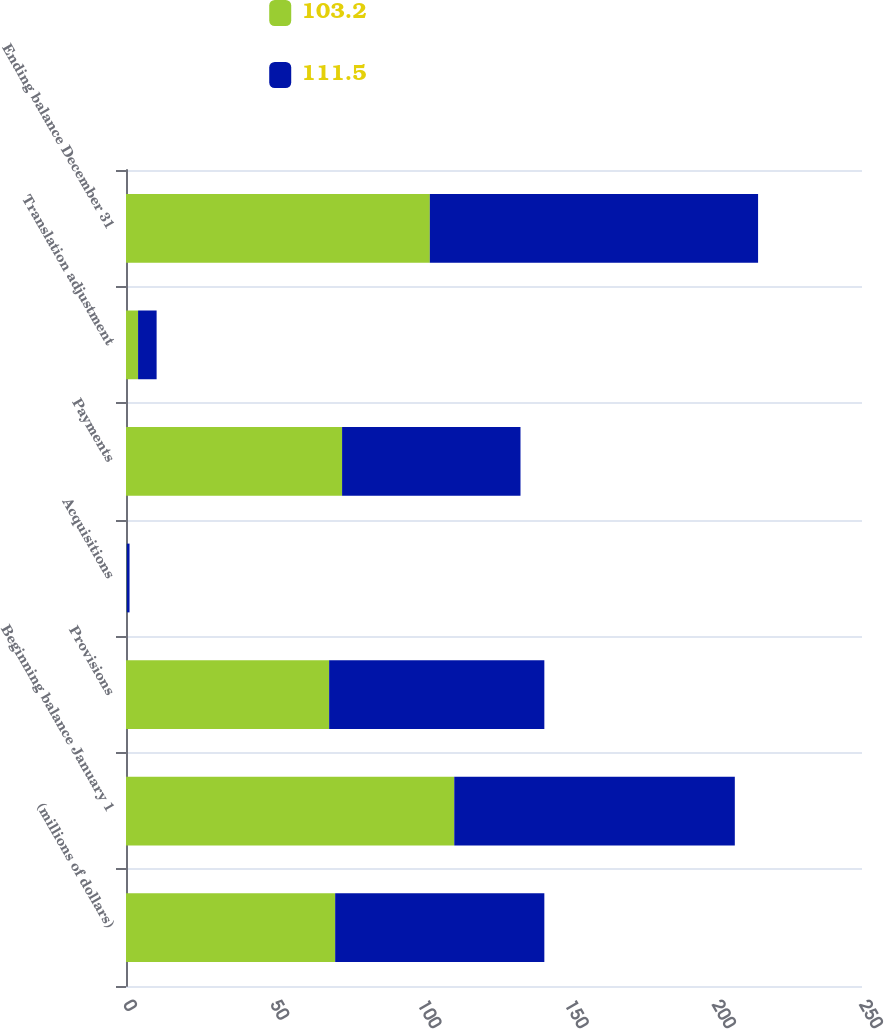<chart> <loc_0><loc_0><loc_500><loc_500><stacked_bar_chart><ecel><fcel>(millions of dollars)<fcel>Beginning balance January 1<fcel>Provisions<fcel>Acquisitions<fcel>Payments<fcel>Translation adjustment<fcel>Ending balance December 31<nl><fcel>103.2<fcel>71.05<fcel>111.5<fcel>69<fcel>0.2<fcel>73.4<fcel>4.1<fcel>103.2<nl><fcel>111.5<fcel>71.05<fcel>95.3<fcel>73.1<fcel>1<fcel>60.6<fcel>6.3<fcel>111.5<nl></chart> 